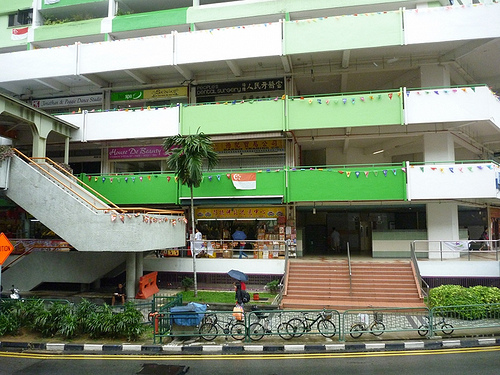<image>
Can you confirm if the umbrella is on the building? No. The umbrella is not positioned on the building. They may be near each other, but the umbrella is not supported by or resting on top of the building. 